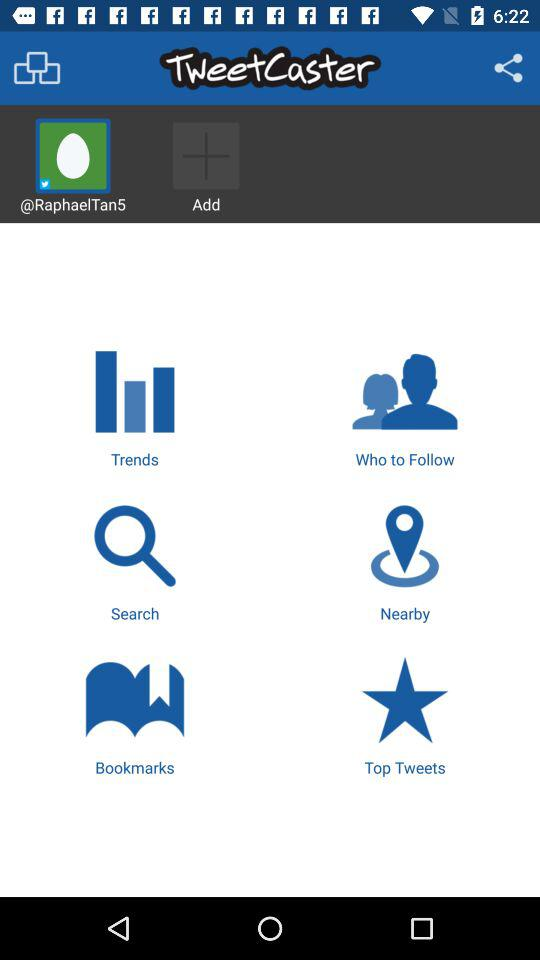What is the name of the application? The name of the application is "TweetCaster". 